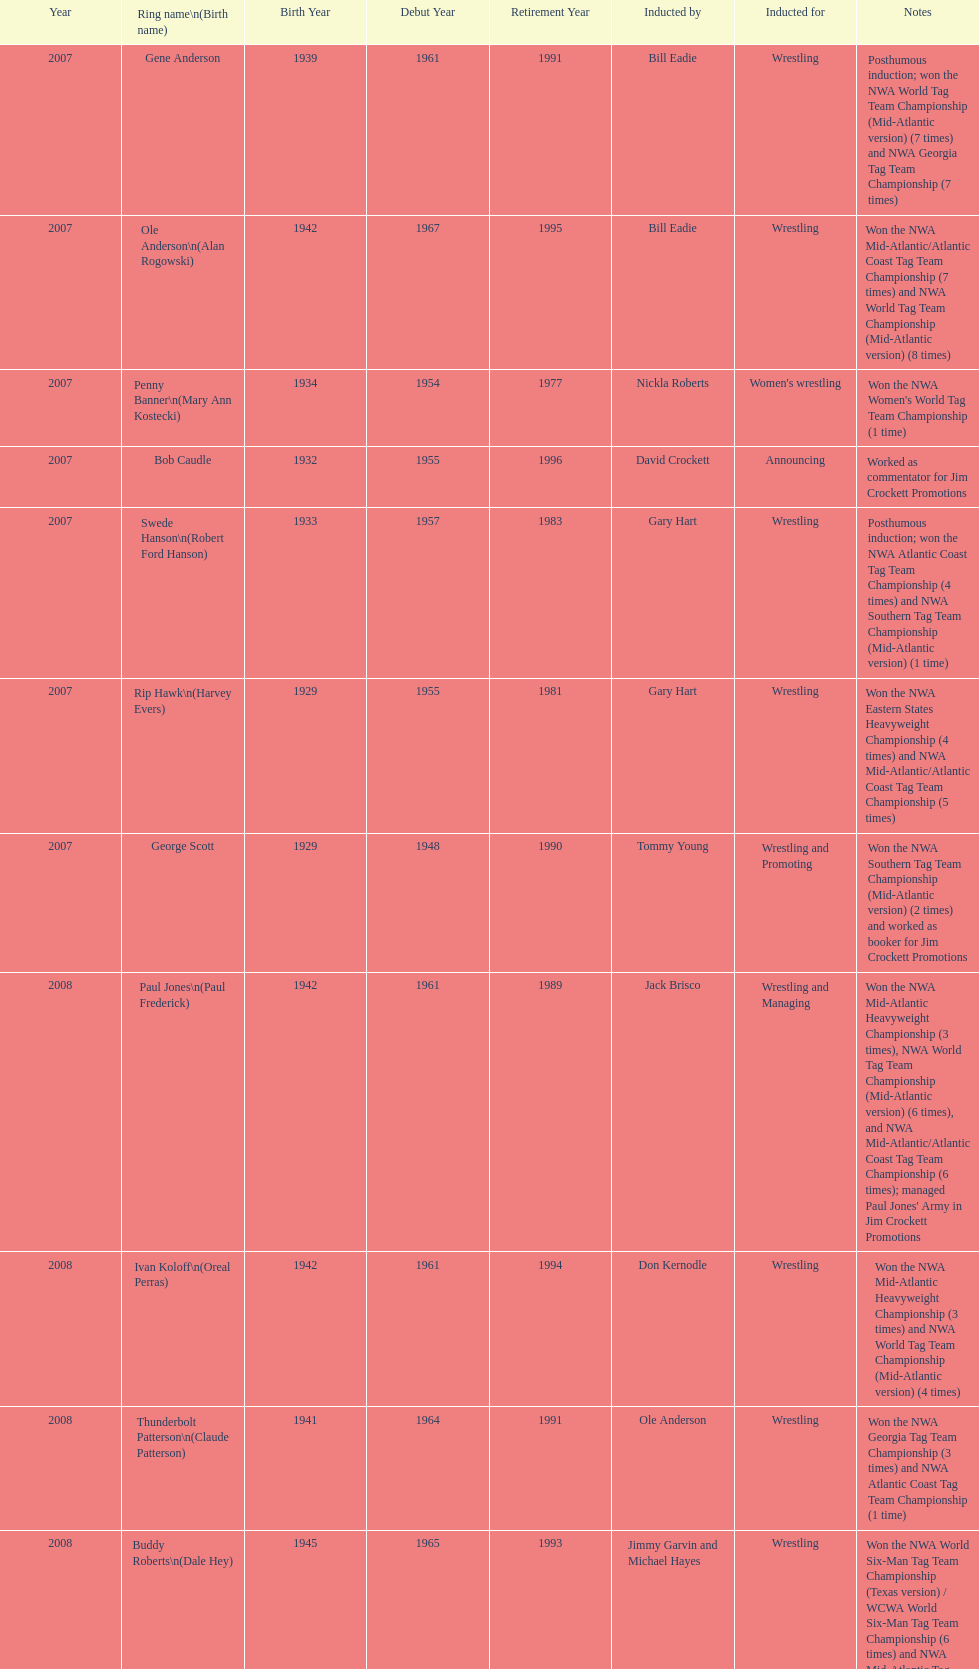Bob caudle was an announcer, who was the other one? Lance Russell. 